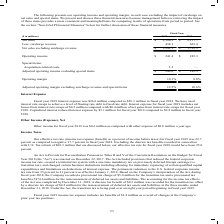According to Carpenter Technology's financial document, What was the amount of operating income in 2019? Based on the financial document, the answer is $241.4 million. Also, What was the amount of operating income as percentage of net sales in 2018? Based on the financial document, the answer is 8.8 percent. Also, In which years was operating income calculated? The document shows two values: 2019 and 2018. From the document: "Fiscal Year ($ in millions) 2019 2018 Net sales $ 2,380.2 $ 2,157.7 Less: surcharge revenue 438.1 365.4 Net sales excluding surcharg Fiscal Year ($ in..." Additionally, In which year was the operating margin larger? According to the financial document, 2019. The relevant text states: "Fiscal Year ($ in millions) 2019 2018 Net sales $ 2,380.2 $ 2,157.7 Less: surcharge revenue 438.1 365.4 Net sales excluding surcharg..." Also, can you calculate: What was the change in the amount of surcharge revenue from 2018 to 2019? Based on the calculation: 438.1-365.4, the result is 72.7 (in millions). This is based on the information: "$ 2,380.2 $ 2,157.7 Less: surcharge revenue 438.1 365.4 Net sales excluding surcharge revenue $ 1,942.1 $ 1,792.3 sales $ 2,380.2 $ 2,157.7 Less: surcharge revenue 438.1 365.4 Net sales excluding surc..." The key data points involved are: 365.4, 438.1. Also, can you calculate: What was the percentage change in the amount of surcharge revenue from 2018 to 2019? To answer this question, I need to perform calculations using the financial data. The calculation is: (438.1-365.4)/365.4, which equals 19.9 (percentage). This is based on the information: "$ 2,380.2 $ 2,157.7 Less: surcharge revenue 438.1 365.4 Net sales excluding surcharge revenue $ 1,942.1 $ 1,792.3 sales $ 2,380.2 $ 2,157.7 Less: surcharge revenue 438.1 365.4 Net sales excluding surc..." The key data points involved are: 365.4, 438.1. 